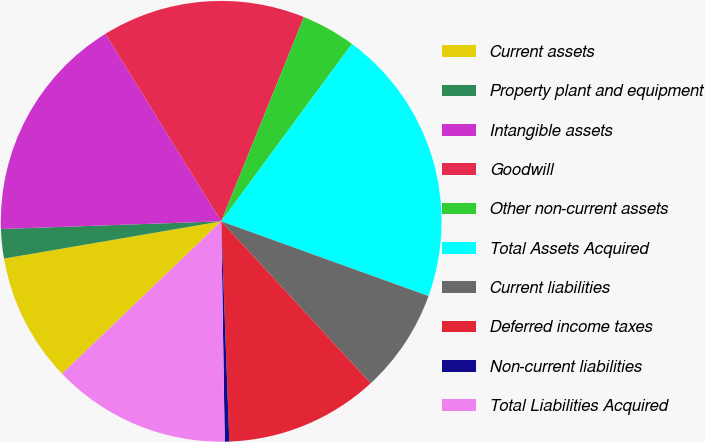Convert chart. <chart><loc_0><loc_0><loc_500><loc_500><pie_chart><fcel>Current assets<fcel>Property plant and equipment<fcel>Intangible assets<fcel>Goodwill<fcel>Other non-current assets<fcel>Total Assets Acquired<fcel>Current liabilities<fcel>Deferred income taxes<fcel>Non-current liabilities<fcel>Total Liabilities Acquired<nl><fcel>9.45%<fcel>2.15%<fcel>16.75%<fcel>14.93%<fcel>3.98%<fcel>20.4%<fcel>7.63%<fcel>11.28%<fcel>0.33%<fcel>13.1%<nl></chart> 